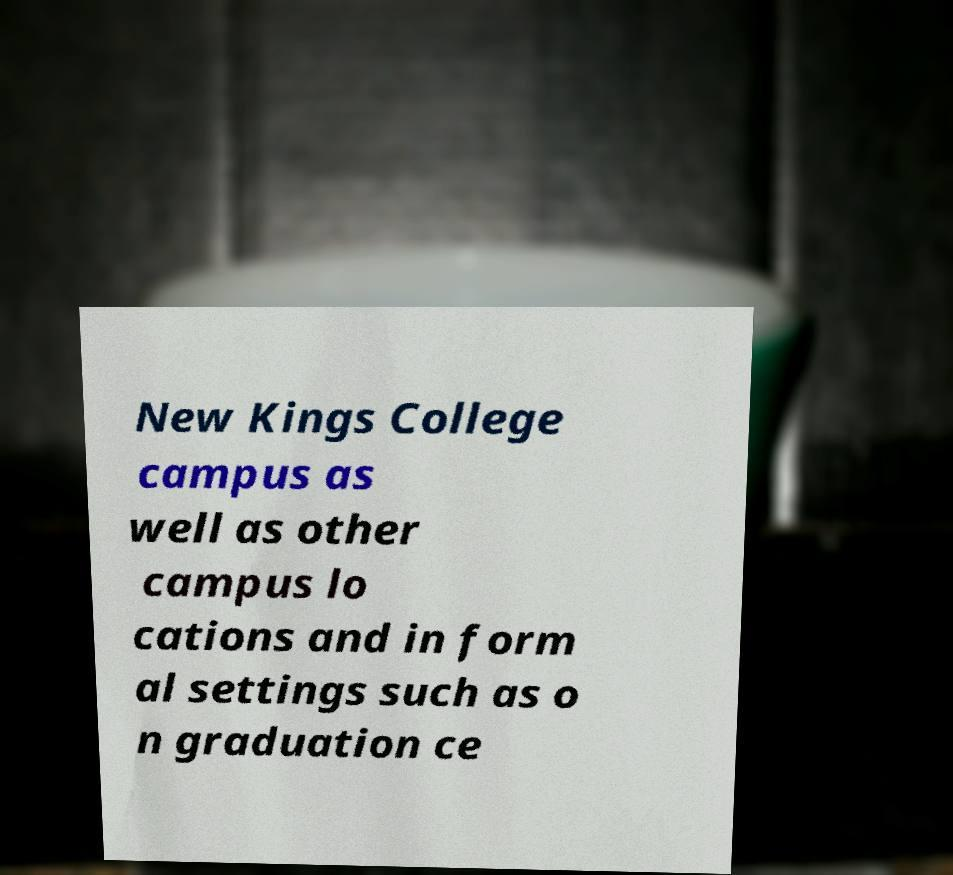There's text embedded in this image that I need extracted. Can you transcribe it verbatim? New Kings College campus as well as other campus lo cations and in form al settings such as o n graduation ce 